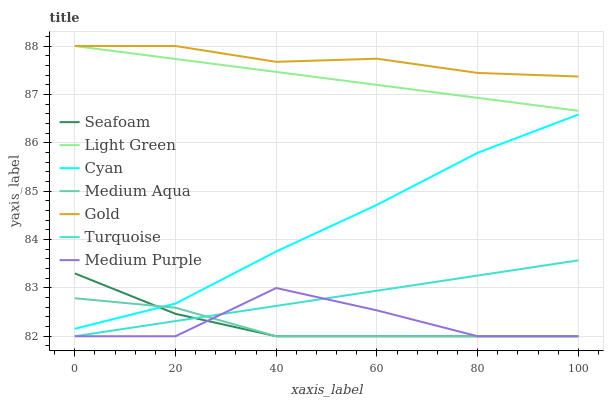Does Medium Aqua have the minimum area under the curve?
Answer yes or no. Yes. Does Gold have the maximum area under the curve?
Answer yes or no. Yes. Does Seafoam have the minimum area under the curve?
Answer yes or no. No. Does Seafoam have the maximum area under the curve?
Answer yes or no. No. Is Light Green the smoothest?
Answer yes or no. Yes. Is Medium Purple the roughest?
Answer yes or no. Yes. Is Gold the smoothest?
Answer yes or no. No. Is Gold the roughest?
Answer yes or no. No. Does Turquoise have the lowest value?
Answer yes or no. Yes. Does Gold have the lowest value?
Answer yes or no. No. Does Light Green have the highest value?
Answer yes or no. Yes. Does Seafoam have the highest value?
Answer yes or no. No. Is Medium Purple less than Light Green?
Answer yes or no. Yes. Is Light Green greater than Cyan?
Answer yes or no. Yes. Does Light Green intersect Gold?
Answer yes or no. Yes. Is Light Green less than Gold?
Answer yes or no. No. Is Light Green greater than Gold?
Answer yes or no. No. Does Medium Purple intersect Light Green?
Answer yes or no. No. 